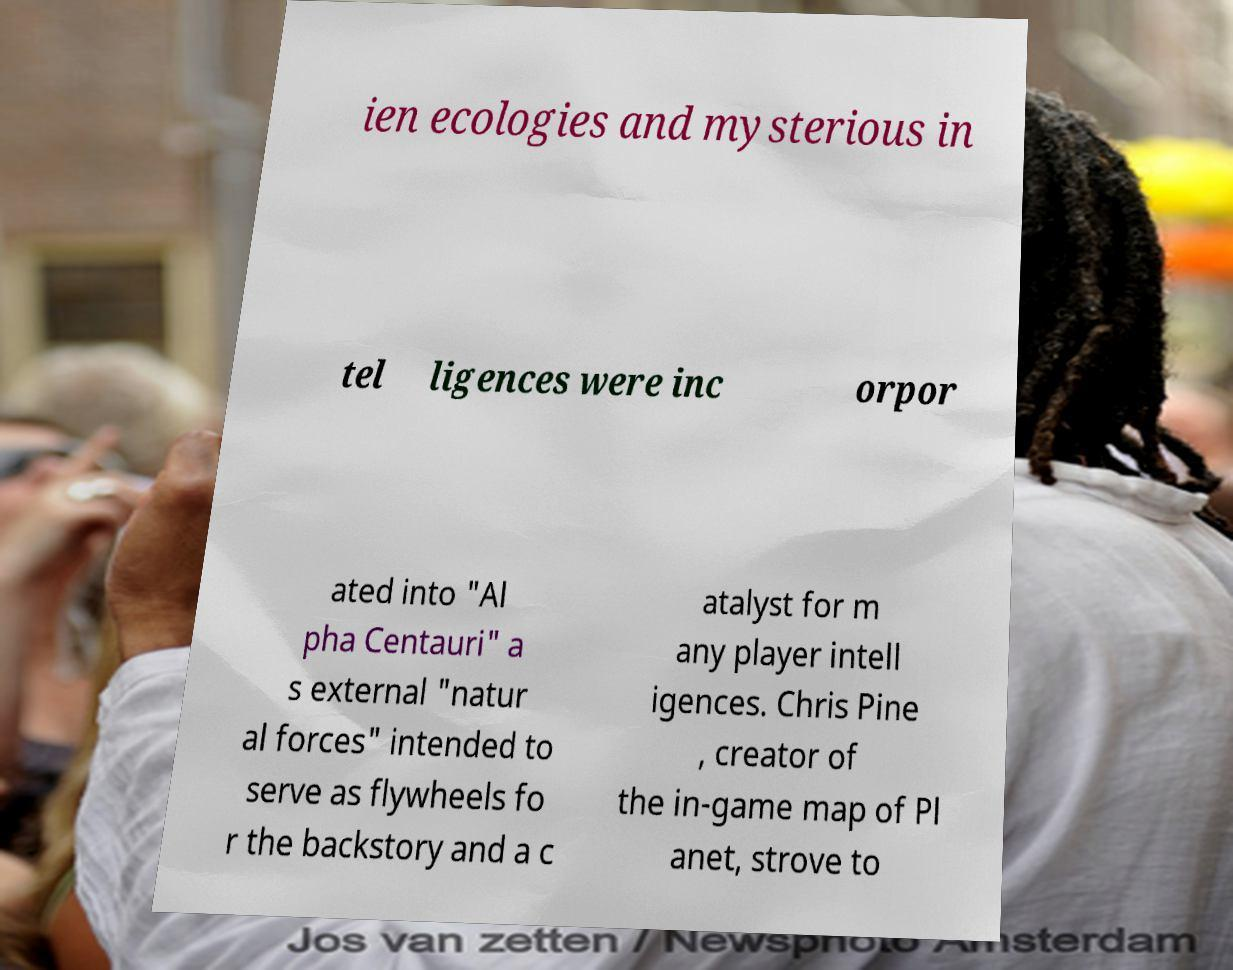I need the written content from this picture converted into text. Can you do that? ien ecologies and mysterious in tel ligences were inc orpor ated into "Al pha Centauri" a s external "natur al forces" intended to serve as flywheels fo r the backstory and a c atalyst for m any player intell igences. Chris Pine , creator of the in-game map of Pl anet, strove to 